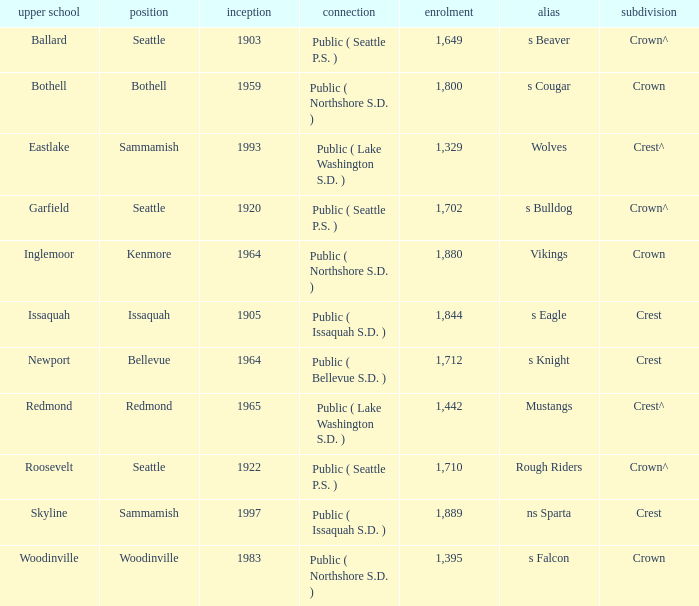What is the affiliation of a location called Issaquah? Public ( Issaquah S.D. ). 